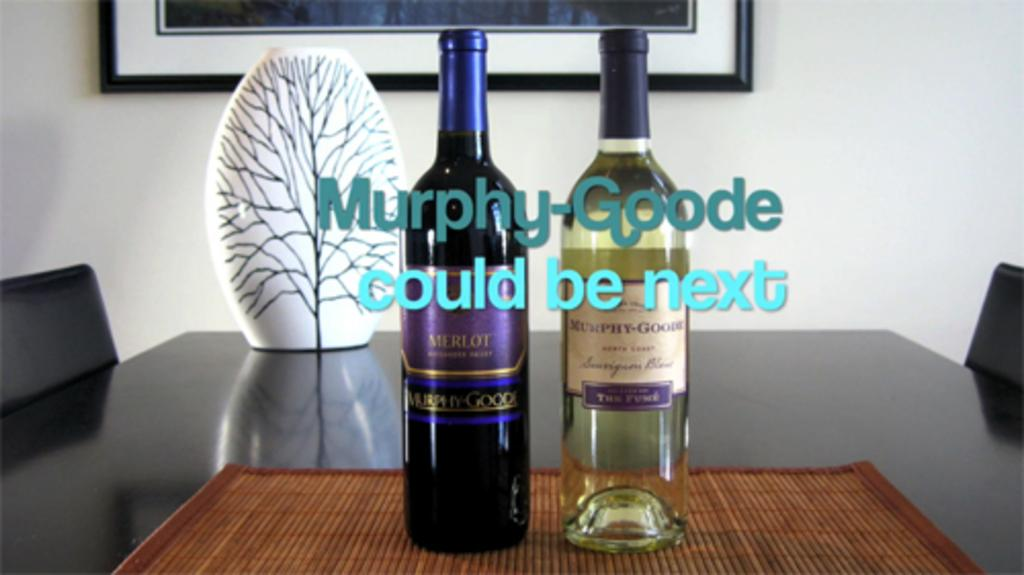<image>
Relay a brief, clear account of the picture shown. Two bottles of wine are on a wooden table with the text Murphy Coode could be next printed in front of them. 